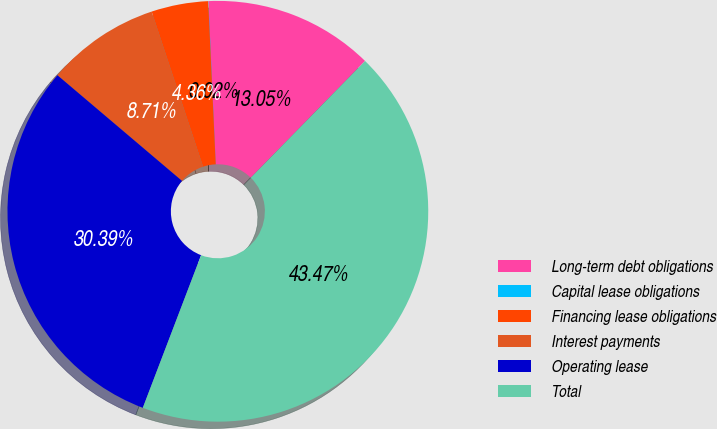Convert chart to OTSL. <chart><loc_0><loc_0><loc_500><loc_500><pie_chart><fcel>Long-term debt obligations<fcel>Capital lease obligations<fcel>Financing lease obligations<fcel>Interest payments<fcel>Operating lease<fcel>Total<nl><fcel>13.05%<fcel>0.02%<fcel>4.36%<fcel>8.71%<fcel>30.39%<fcel>43.47%<nl></chart> 